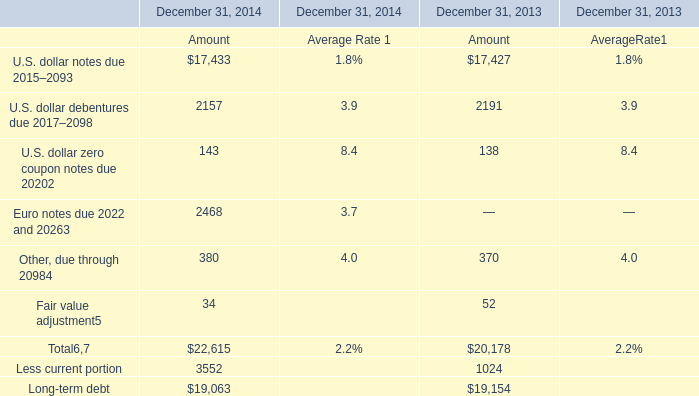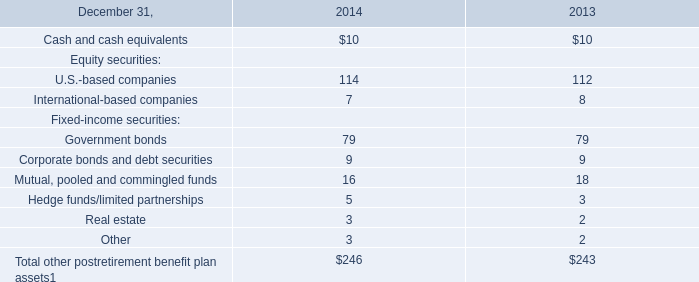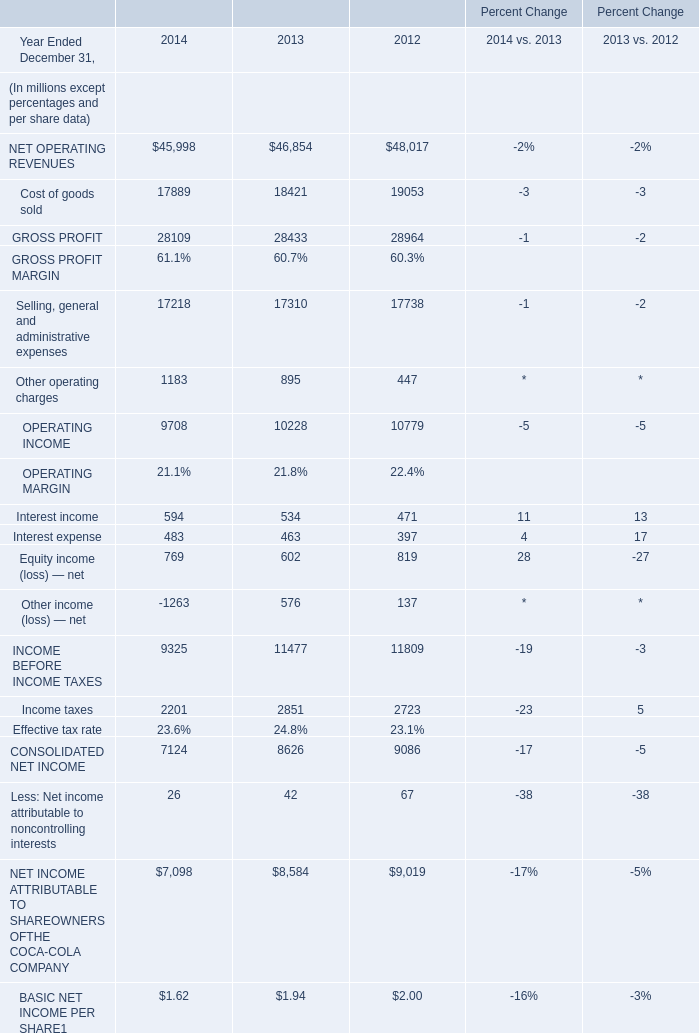What is the growing rate of Interest expense in the year with the most Interest income? (in %) 
Computations: ((483 - 463) / 463)
Answer: 0.0432. 